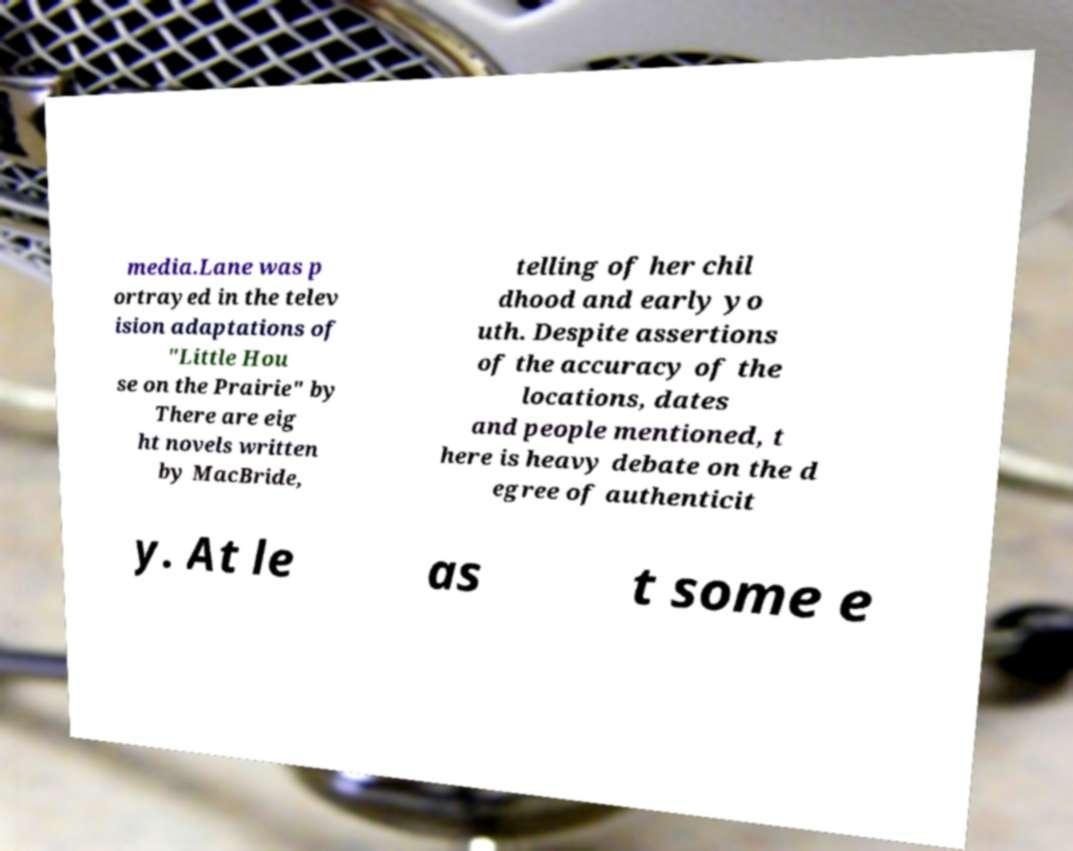For documentation purposes, I need the text within this image transcribed. Could you provide that? media.Lane was p ortrayed in the telev ision adaptations of "Little Hou se on the Prairie" by There are eig ht novels written by MacBride, telling of her chil dhood and early yo uth. Despite assertions of the accuracy of the locations, dates and people mentioned, t here is heavy debate on the d egree of authenticit y. At le as t some e 